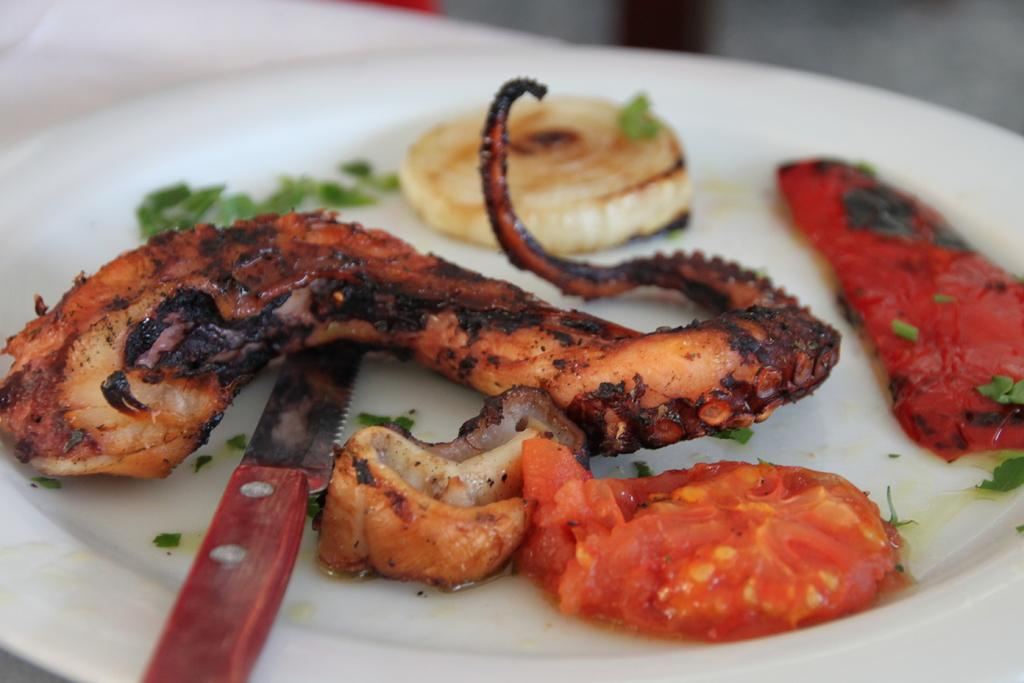What is on the plate in the image? There is meat on the plate. Are there any other food items visible on the plate? Yes, there is additional food stuff beside the meat. What utensil is present on the plate? There is a knife on the plate at the bottom. What type of gold leaf can be seen decorating the meat on the plate? There is no gold leaf or any decoration mentioned in the image; it only states that there is meat on the plate. 